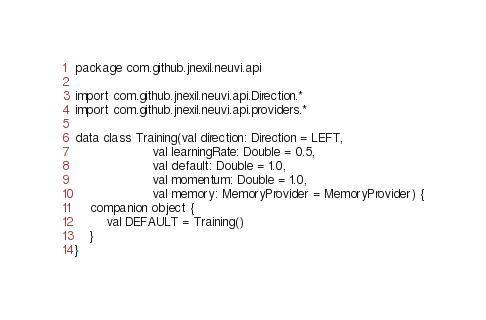<code> <loc_0><loc_0><loc_500><loc_500><_Kotlin_>package com.github.jnexil.neuvi.api

import com.github.jnexil.neuvi.api.Direction.*
import com.github.jnexil.neuvi.api.providers.*

data class Training(val direction: Direction = LEFT,
                    val learningRate: Double = 0.5,
                    val default: Double = 1.0,
                    val momentum: Double = 1.0,
                    val memory: MemoryProvider = MemoryProvider) {
    companion object {
        val DEFAULT = Training()
    }
}</code> 